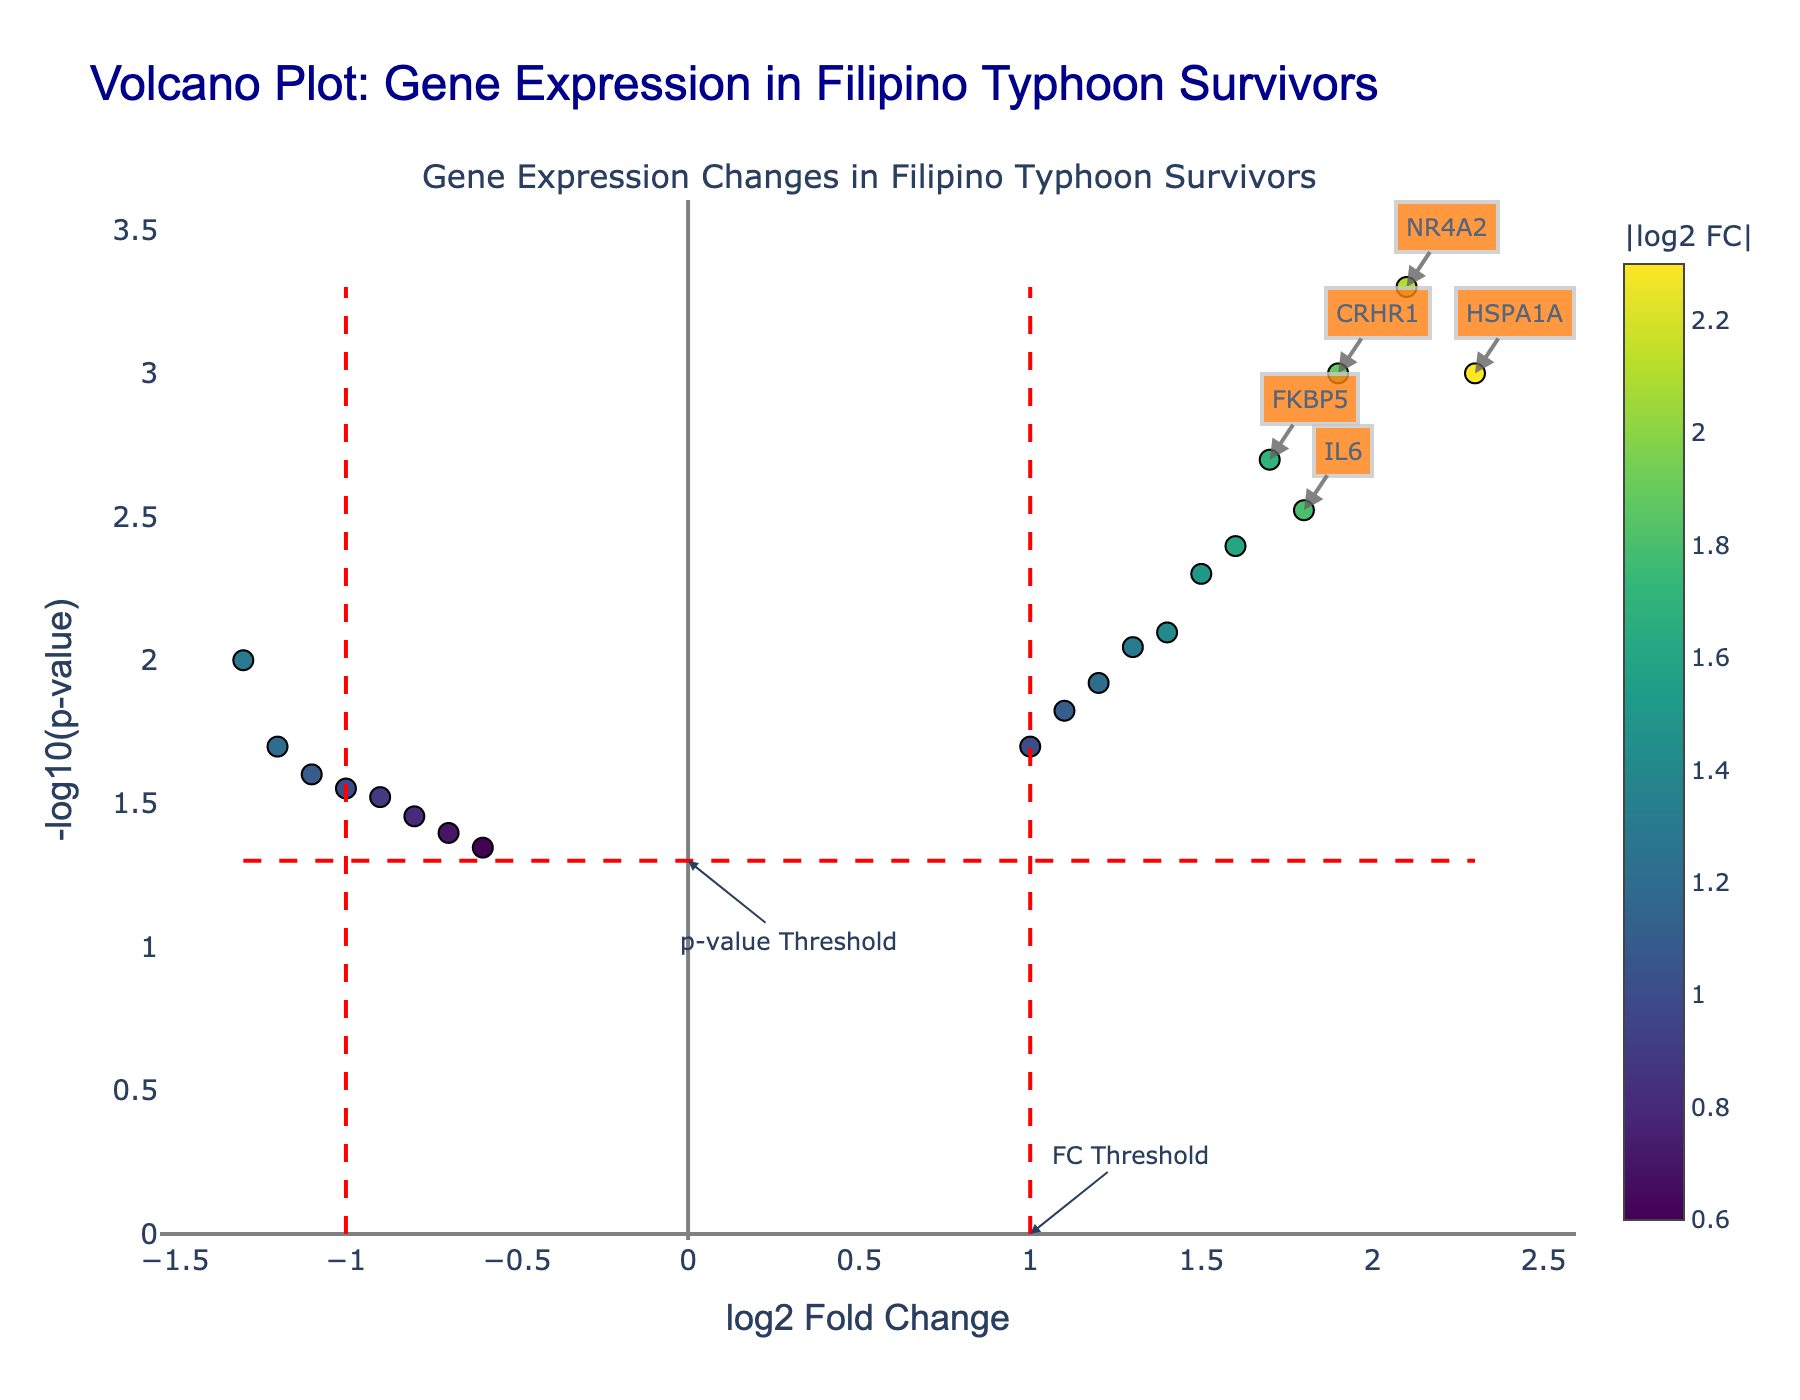What is the title of the volcano plot? The title is displayed at the top of the figure and provides a summary of what the plot represents. By reading this title, we get an idea of the context of the data.
Answer: Volcano Plot: Gene Expression in Filipino Typhoon Survivors What does the x-axis represent in the plot? The x-axis shows "log2 Fold Change," which measures the logarithmic differences in gene expression levels between the sample groups (e.g., with and without typhoon-related stress).
Answer: log2 Fold Change What does the y-axis represent in the plot? The y-axis represents "-log10(p-value)," which is the negative logarithm of the p-value. This axis is used to emphasize the statistical significance of the observed differences in gene expression.
Answer: -log10(p-value) Which gene has the highest -log10(p-value)? By looking at the data points on the plot, we identify the one with the highest value on the y-axis. The gene at the highest point is annotated with its name.
Answer: NR4A2 How many genes are upregulated with a log2 fold change greater than 1 and statistically significant with p < 0.05? To determine this, we need to count the number of genes to the right of the x-axis threshold (log2 FC > 1) and above the y-axis threshold (-log10(p) > 1.3). Both fold change and p-value thresholds are indicated by dashed red lines.
Answer: 8 genes What are the downregulated genes with log2 fold change less than -1? We identify the genes to the left of the x-axis threshold (log2 FC < -1) and list them based on their position on the plot. These genes are NR3C1, SLC6A4, and MAOA.
Answer: NR3C1, SLC6A4, MAOA Which gene has the highest log2 fold change among the upregulated genes? We identify the gene with the highest log2 fold change value among those to the right of the vertical dashed line at log2 FC = 1. The gene with the maximum x-axis value in this subset is HSPA1A.
Answer: HSPA1A What is the p-value threshold used in the plot? The p-value threshold is indicated by the horizontal dashed line on the plot, which is drawn at -log10(p) = 1.3. This corresponds to a p-value of 0.05.
Answer: 0.05 Compare the log2 fold change between HSPA1A and SLC6A4. Which is higher? We look at the log2 fold change values for HSPA1A and SLC6A4. HSPA1A has a log2 FC of 2.3, whereas SLC6A4 has a log2 FC of -1.3.
Answer: HSPA1A Which genes are highlighted with annotations as top differentially expressed genes? Annotations are added to the top 5 genes based on their -log10(p-value). These genes are HSPA1A, IL6, CRHR1, FKBP5, and NR4A2.
Answer: HSPA1A, IL6, CRHR1, FKBP5, NR4A2 